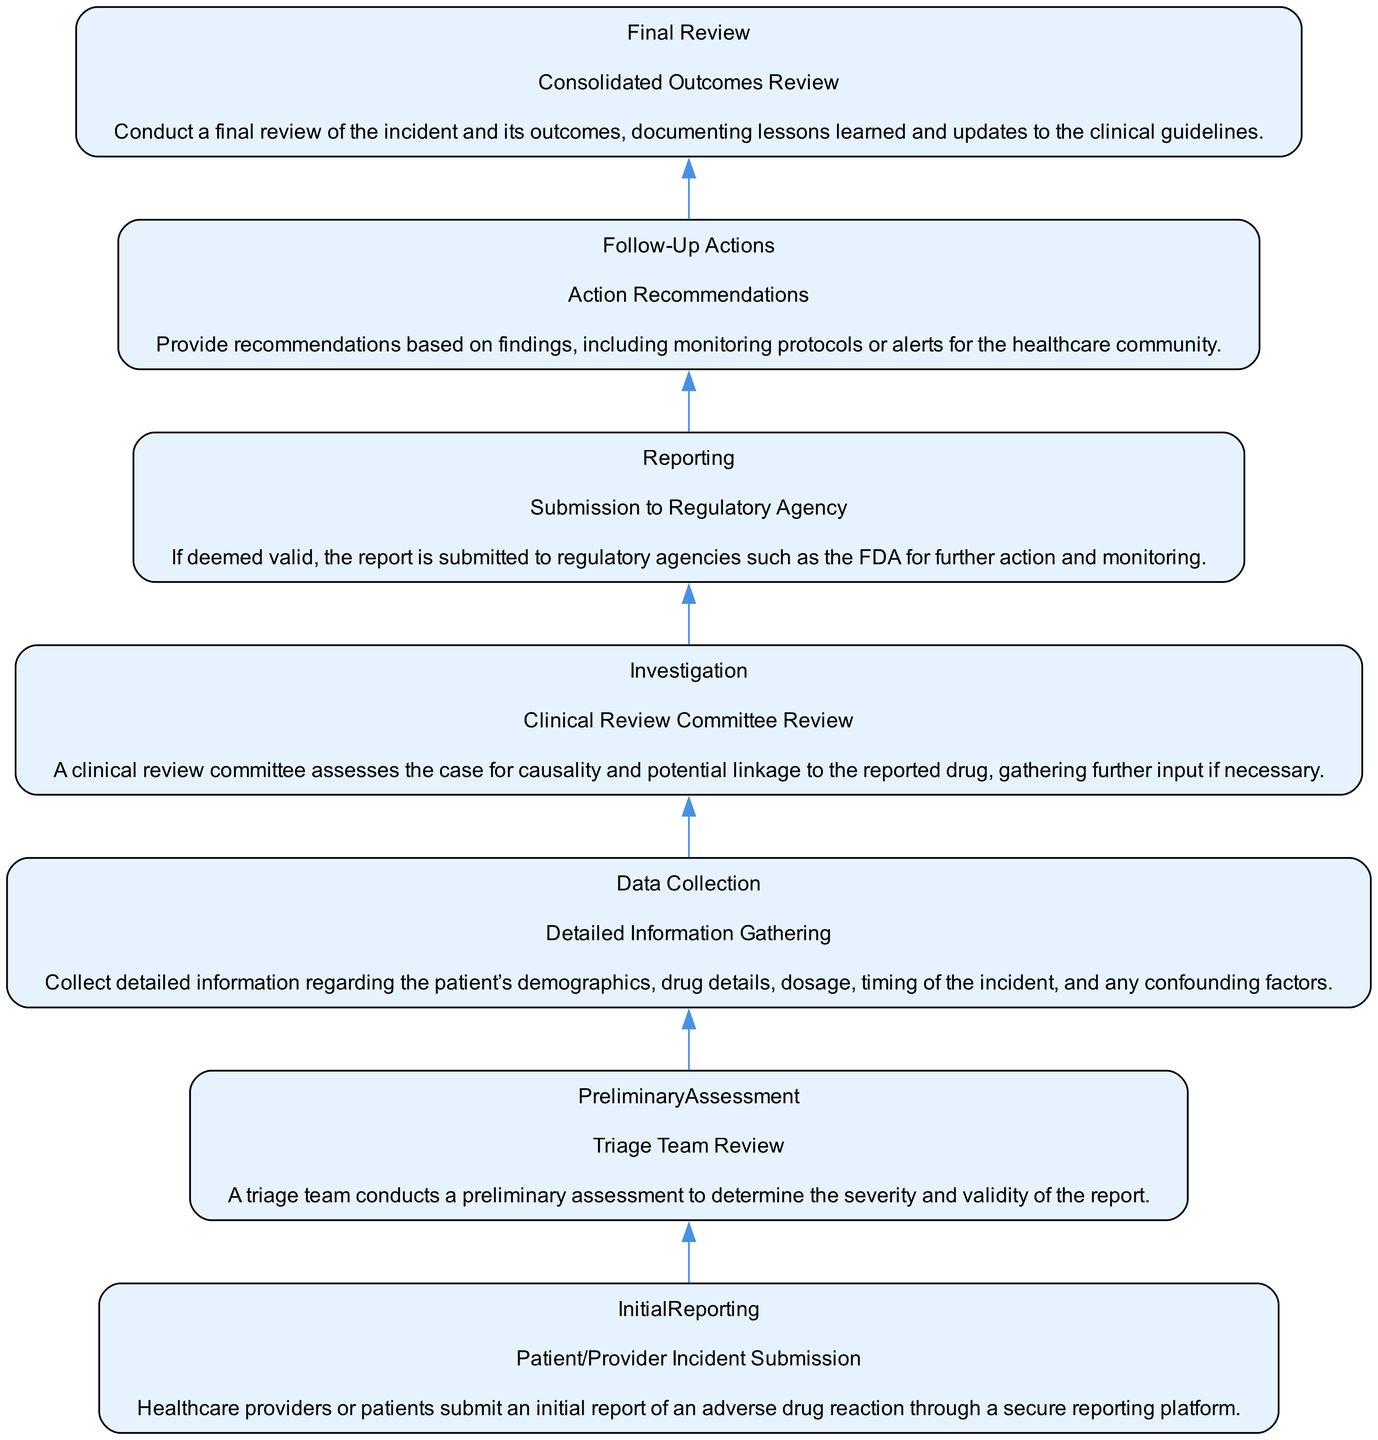What is the first step in the incident reporting flow? The first step in the incident reporting flow is "Patient/Provider Incident Submission," which involves healthcare providers or patients submitting an initial report through a secure platform.
Answer: Patient/Provider Incident Submission How many steps are there in the diagram? The diagram shows a total of seven steps in the incident reporting flow, including distinct processes from initial reporting to final review.
Answer: Seven What action follows the "Triage Team Review"? The action that follows the "Triage Team Review" is "Detailed Information Gathering," where detailed patient and incident information is collected after the triage assessment.
Answer: Detailed Information Gathering What is the final step in the flow chart? The final step in the flow chart is "Consolidated Outcomes Review," which involves conducting a final review of the incident outcomes and documenting lessons learned.
Answer: Consolidated Outcomes Review Which element is associated with submission to regulatory agencies? The element associated with submission to regulatory agencies is "Submission to Regulatory Agency," where valid reports are sent to organizations like the FDA for monitoring.
Answer: Submission to Regulatory Agency What is the purpose of the "Action Recommendations" step? The "Action Recommendations" step provides recommendations based on the findings from the investigation, including monitoring protocols or alerts to the healthcare community about the incident.
Answer: Action Recommendations Which step directly follows the "Clinical Review Committee Review"? The step directly following the "Clinical Review Committee Review" is "Submission to Regulatory Agency," indicating that valid cases proceed to regulatory submission.
Answer: Submission to Regulatory Agency How does the "Detailed Information Gathering" relate to initial reporting? "Detailed Information Gathering" relates to initial reporting as it occurs after the first step and involves collecting comprehensive data about the incident initially reported by patients or providers.
Answer: Collecting comprehensive data What does the triage team assess during the preliminary assessment? During the preliminary assessment, the triage team assesses the severity and validity of the adverse drug reaction report submitted by the patients or healthcare providers.
Answer: Severity and validity 